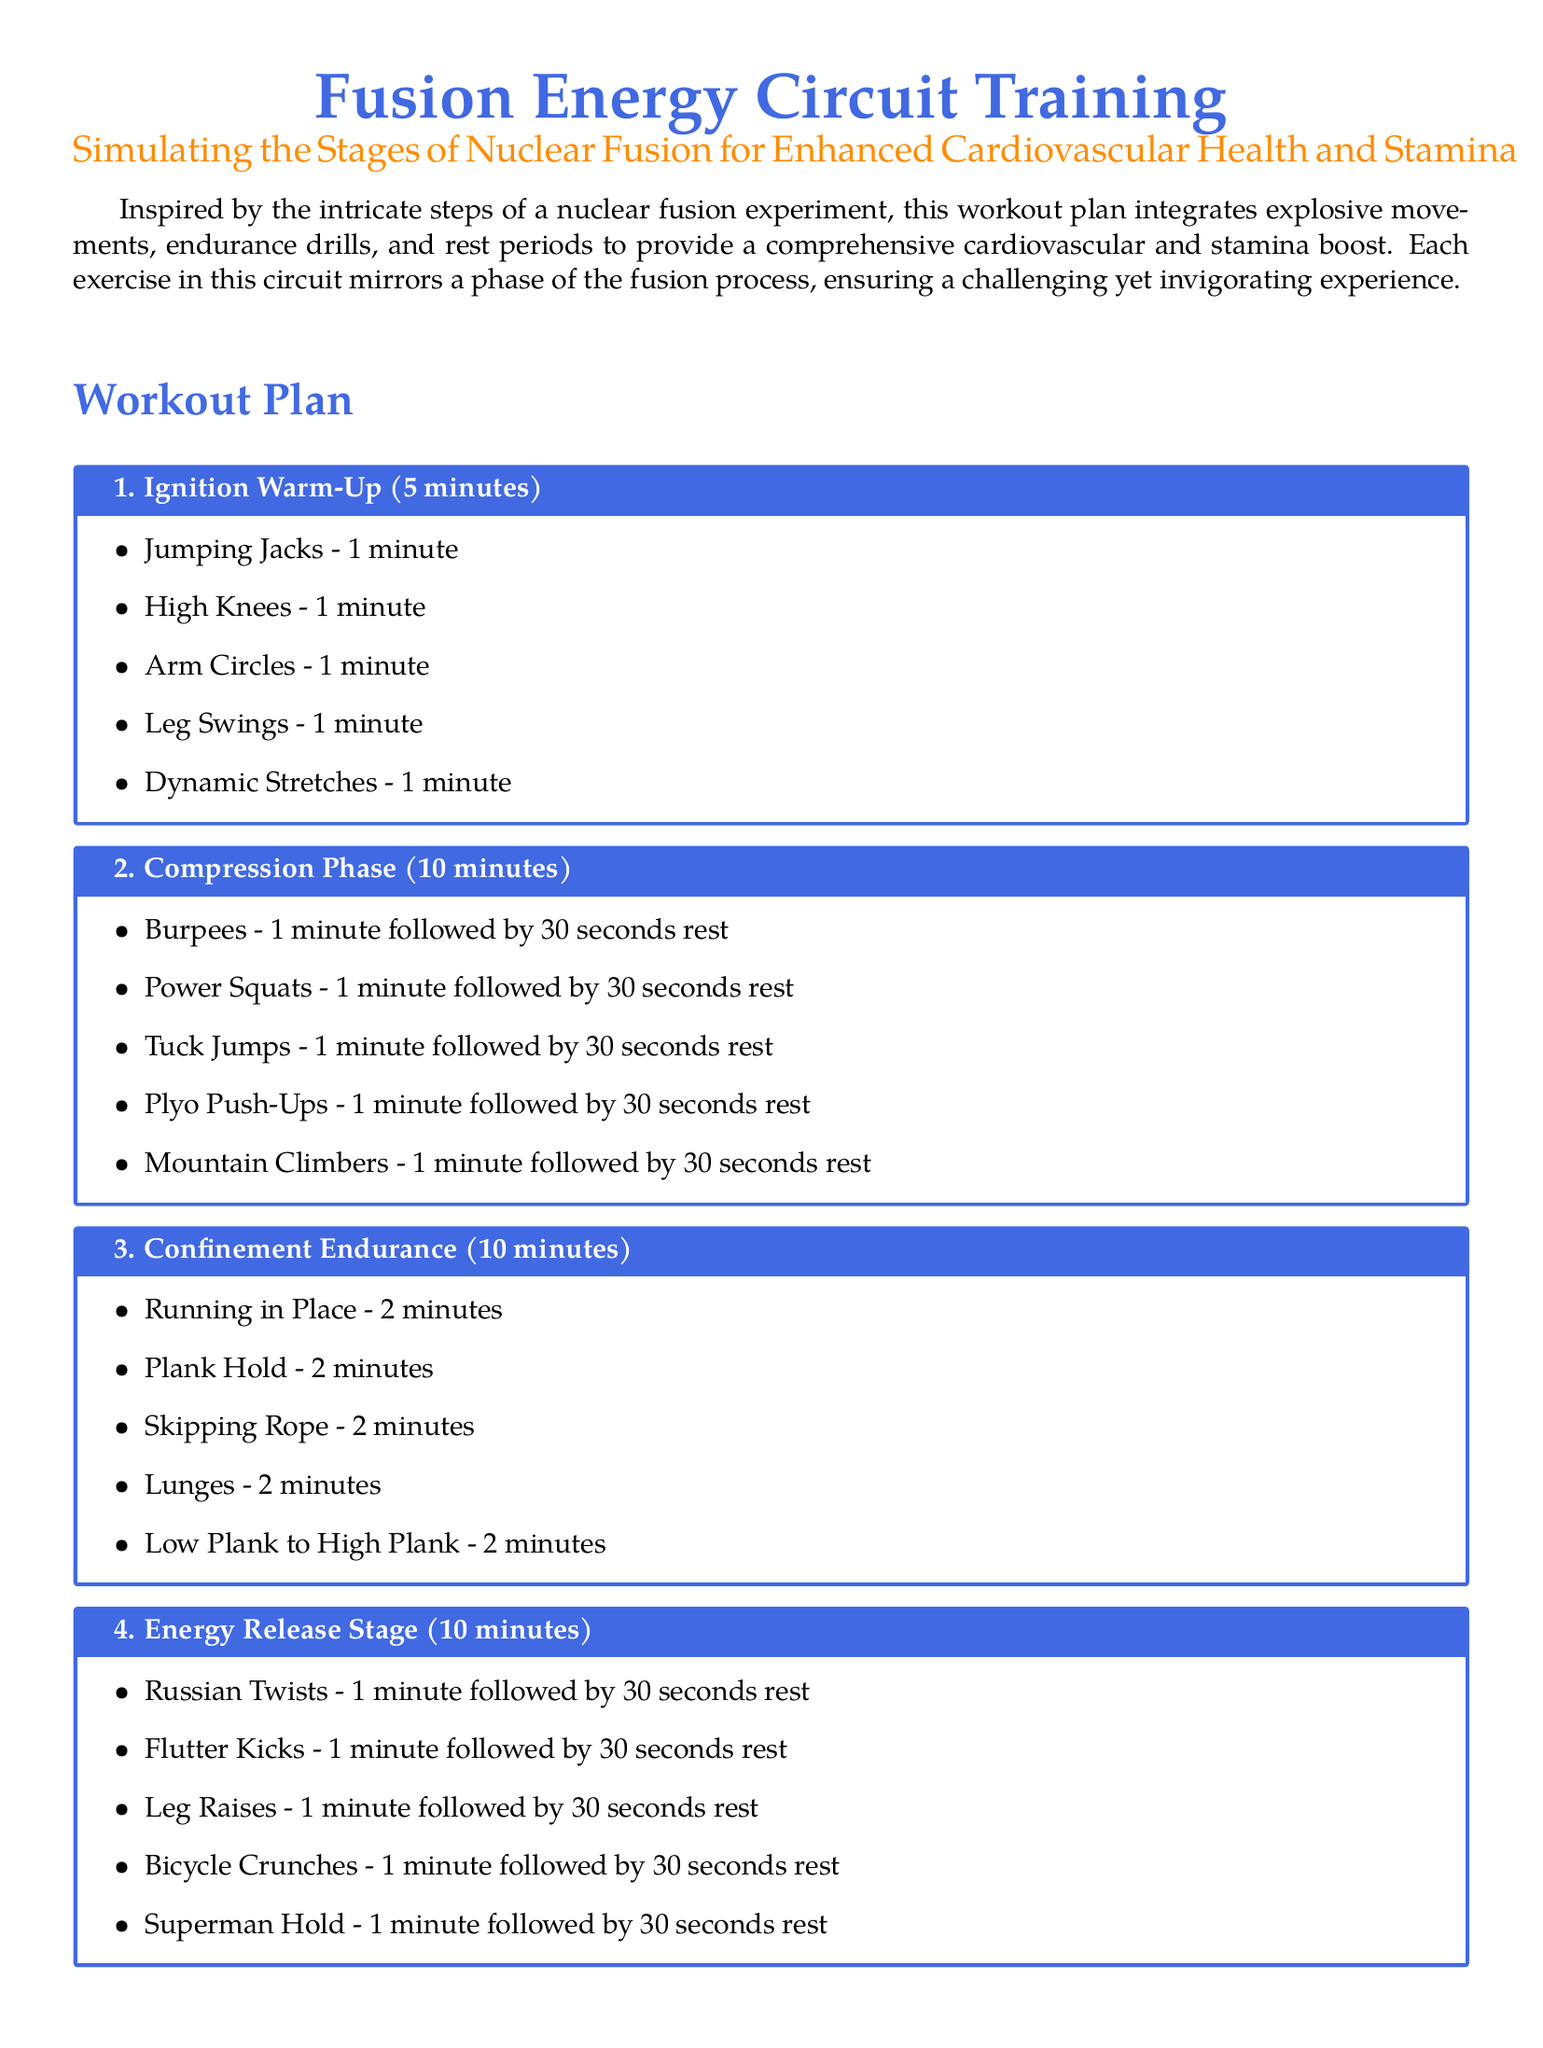What is the duration of the Ignition Warm-Up? The duration of the Ignition Warm-Up is specified in the document as 5 minutes.
Answer: 5 minutes How many exercises are included in the Compression Phase? The Compression Phase contains a list of five exercises, as enumerated in the document.
Answer: 5 exercises What exercise is performed first in the Energy Release Stage? The first exercise listed in the Energy Release Stage is Russian Twists, as seen in the document.
Answer: Russian Twists What type of workout routine is this plan inspired by? The workout plan is inspired by the intricate steps of a nuclear fusion experiment, as stated in the introduction.
Answer: nuclear fusion experiment How long is the total duration of the Confinement Endurance segment? The document states that the Confinement Endurance segment lasts for 10 minutes.
Answer: 10 minutes What is the last exercise in the Cooldown and Recovery section? The last exercise listed in the Cooldown and Recovery section is Deep Breathing Exercises, as per the document.
Answer: Deep Breathing Exercises What phase of workout does the Cooldown and Recovery section represent? The Cooldown and Recovery section is designed to reflect the recovery aspect after intense workouts, much like the ending phase of a process.
Answer: recovery What is the primary goal of the Fusion Energy Circuit Training? The document mentions that the primary goal is to enhance cardiovascular health and stamina.
Answer: cardiovascular health and stamina 